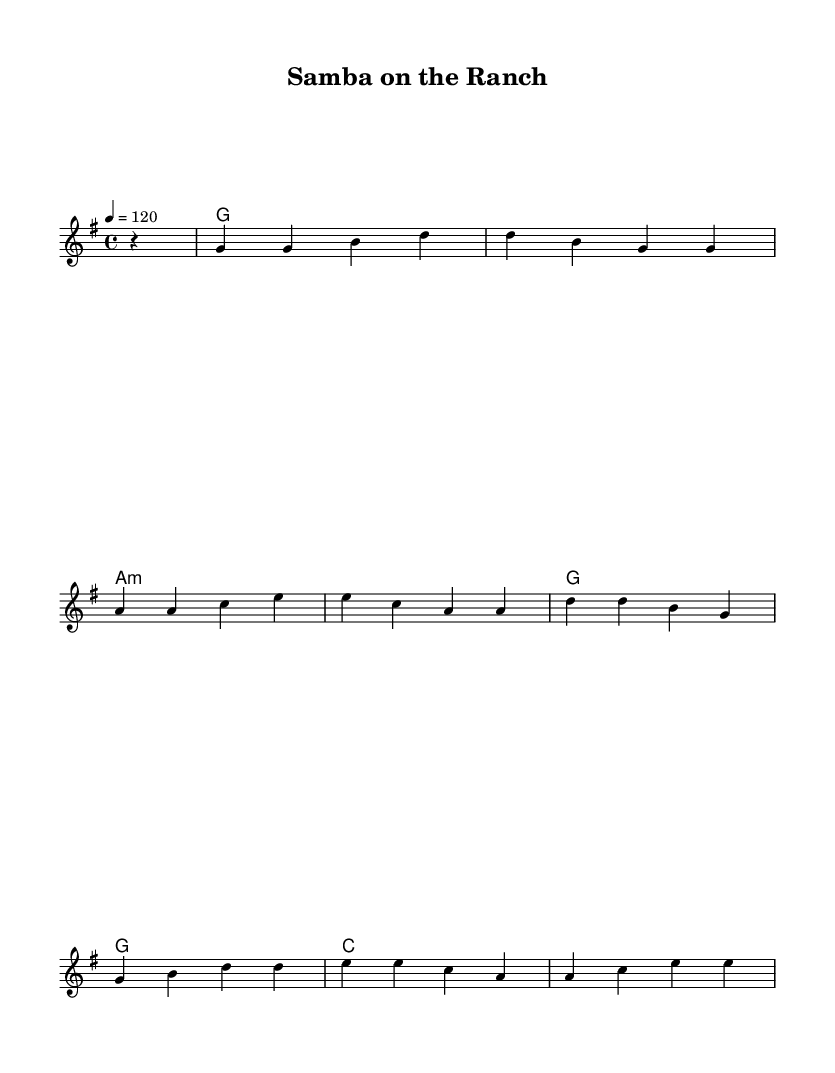What is the key signature of this music? The key signature is G major, which has one sharp (F#). This is indicated at the beginning of the staff.
Answer: G major What is the time signature of this music? The time signature is 4/4, which is indicated at the beginning of the staff. It means there are four beats in each measure and the quarter note gets one beat.
Answer: 4/4 What is the tempo marking for this piece? The tempo marking shows that the piece should be played at a speed of 120 beats per minute, indicated by the number "120" below the quarter note symbol.
Answer: 120 How many measures are in the melody? Counting the measures in the melody part indicates there are eight measures total in this section of music. Each measure is separated by a vertical line.
Answer: 8 What chord follows the G major chord in the progression? Observing the chord progression reveals that after the G major chord, the next chord listed is A minor. It is the next chord shown in the harmonies section, immediately following the G major chord.
Answer: A minor What musical style does this piece represent? The music shows a characteristic blend of country and rock styles, evident from the rhythm and chord structure typical of country rock music. This fusion is intended to reflect Brazilian and American influences as highlighted in the theme.
Answer: Country rock Which notes are the first notes in the melody? The first notes in the melody, represented at the beginning of the score, are G and G, both quarter notes, as indicated in the melody line.
Answer: G, G 